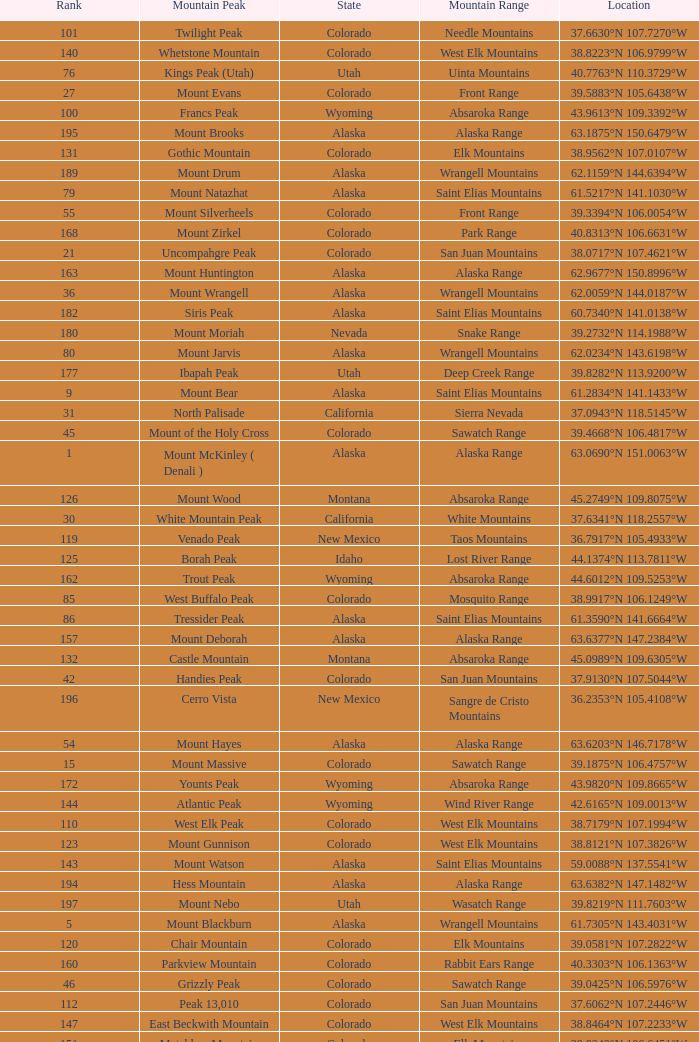What is the mountain peak when the location is 37.5775°n 105.4856°w? Blanca Peak. 